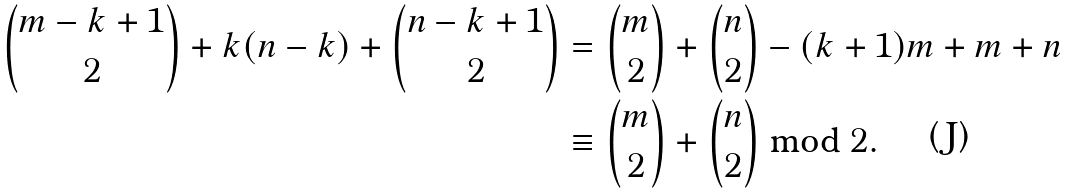<formula> <loc_0><loc_0><loc_500><loc_500>\binom { m - k + 1 } { 2 } + k ( n - k ) + \binom { n - k + 1 } { 2 } & = \binom { m } { 2 } + \binom { n } { 2 } - ( k + 1 ) m + m + n \\ & \equiv \binom { m } { 2 } + \binom { n } { 2 } \bmod 2 .</formula> 